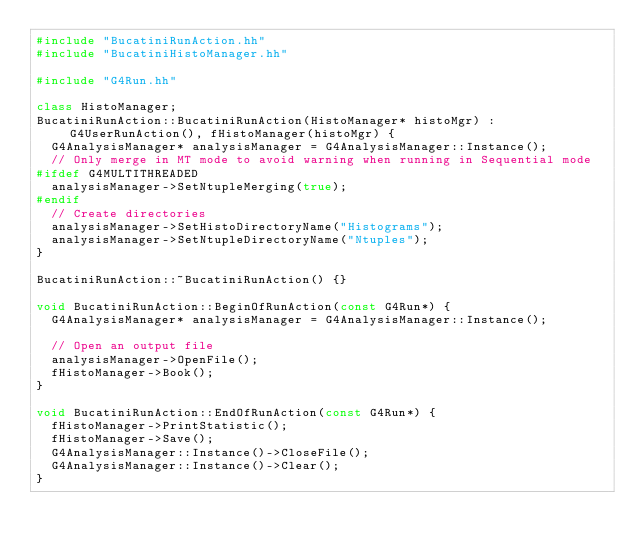Convert code to text. <code><loc_0><loc_0><loc_500><loc_500><_C++_>#include "BucatiniRunAction.hh"
#include "BucatiniHistoManager.hh"

#include "G4Run.hh"

class HistoManager;
BucatiniRunAction::BucatiniRunAction(HistoManager* histoMgr) : G4UserRunAction(), fHistoManager(histoMgr) {
  G4AnalysisManager* analysisManager = G4AnalysisManager::Instance();
  // Only merge in MT mode to avoid warning when running in Sequential mode
#ifdef G4MULTITHREADED
  analysisManager->SetNtupleMerging(true);
#endif
  // Create directories
  analysisManager->SetHistoDirectoryName("Histograms");
  analysisManager->SetNtupleDirectoryName("Ntuples");
}

BucatiniRunAction::~BucatiniRunAction() {}

void BucatiniRunAction::BeginOfRunAction(const G4Run*) {
  G4AnalysisManager* analysisManager = G4AnalysisManager::Instance();

  // Open an output file
  analysisManager->OpenFile();
  fHistoManager->Book();
}

void BucatiniRunAction::EndOfRunAction(const G4Run*) {
  fHistoManager->PrintStatistic();
  fHistoManager->Save();
  G4AnalysisManager::Instance()->CloseFile();
  G4AnalysisManager::Instance()->Clear();
}
</code> 